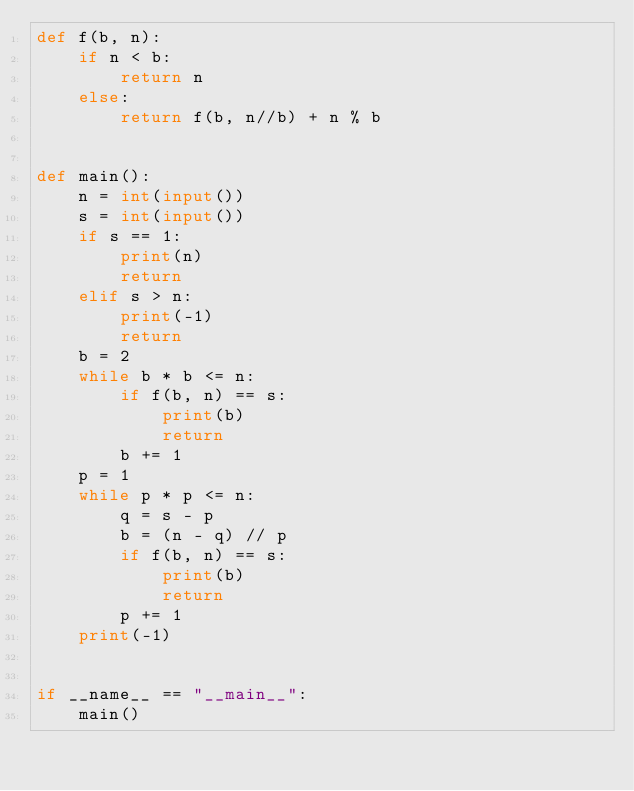Convert code to text. <code><loc_0><loc_0><loc_500><loc_500><_Python_>def f(b, n):
    if n < b:
        return n
    else:
        return f(b, n//b) + n % b


def main():
    n = int(input())
    s = int(input())
    if s == 1:
        print(n)
        return
    elif s > n:
        print(-1)
        return
    b = 2
    while b * b <= n:
        if f(b, n) == s:
            print(b)
            return
        b += 1
    p = 1
    while p * p <= n:
        q = s - p
        b = (n - q) // p
        if f(b, n) == s:
            print(b)
            return
        p += 1
    print(-1)


if __name__ == "__main__":
    main()
</code> 